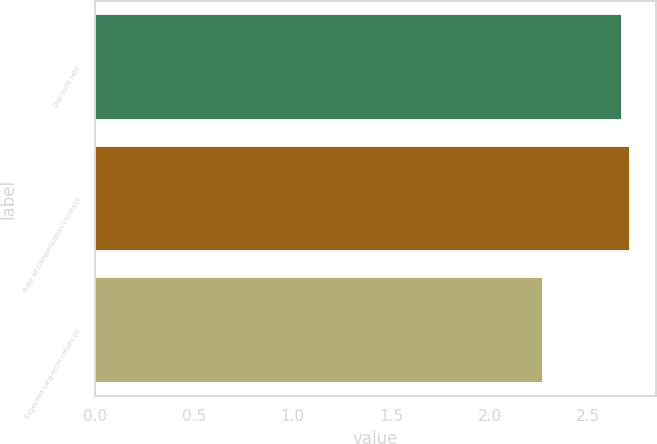Convert chart to OTSL. <chart><loc_0><loc_0><loc_500><loc_500><bar_chart><fcel>Discount rate<fcel>Rate of compensation increase<fcel>Expected long-term return on<nl><fcel>2.67<fcel>2.71<fcel>2.27<nl></chart> 